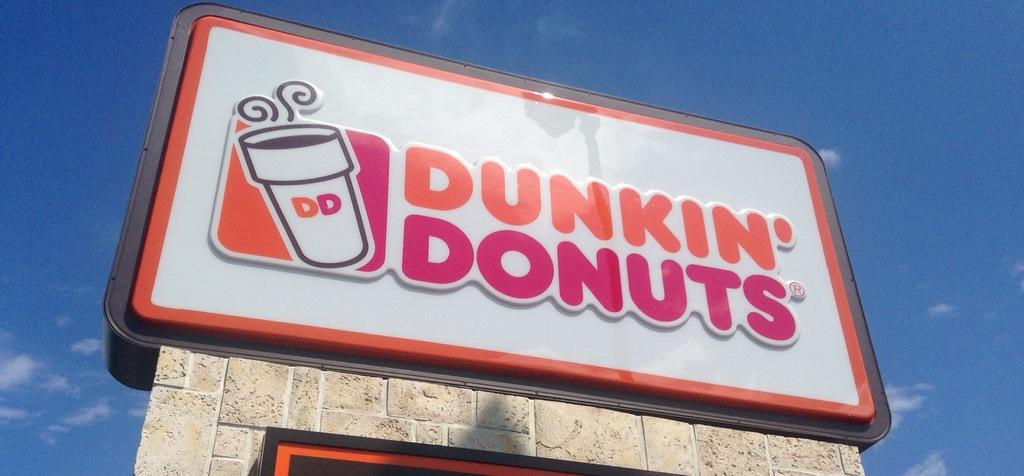What is on the cup?
Offer a terse response. Dd. Where is this?
Keep it short and to the point. Dunkin' donuts. 